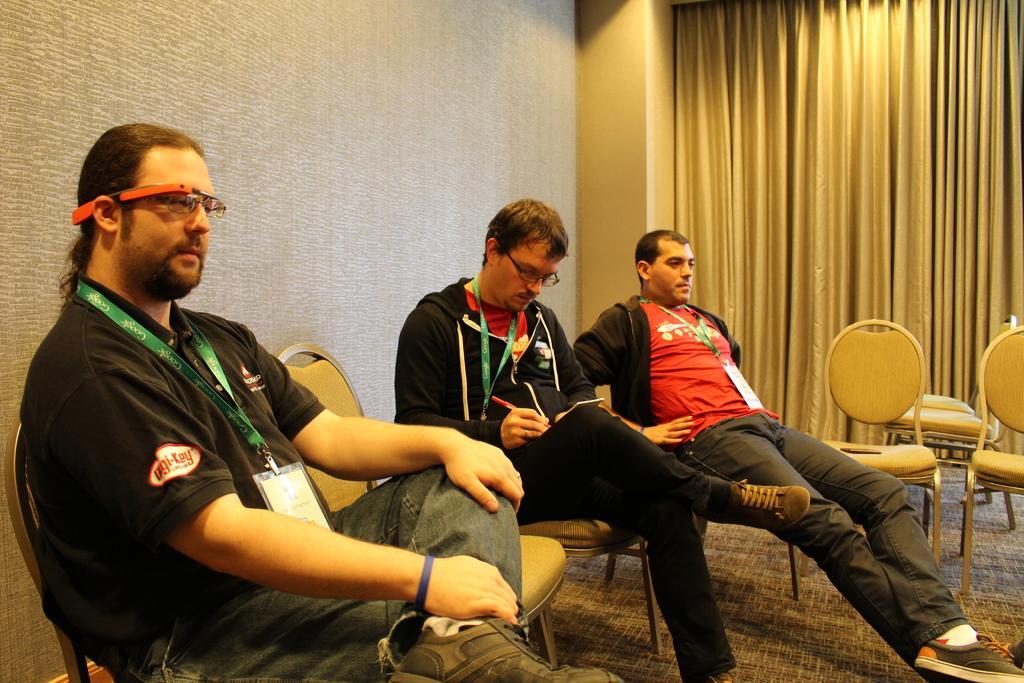Please provide a concise description of this image. The photo is taken inside a room. There are few chairs. Three people are sitting on the chairs. The person on the left is wearing black t-shirt. The other two persons are wearing red t-shirt. On the top right there is curtain. Behind the person there is a grey wall. 